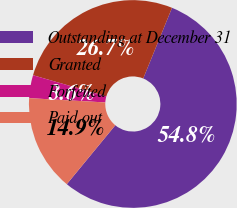Convert chart. <chart><loc_0><loc_0><loc_500><loc_500><pie_chart><fcel>Outstanding at December 31<fcel>Granted<fcel>Forfeited<fcel>Paid out<nl><fcel>54.8%<fcel>26.69%<fcel>3.57%<fcel>14.93%<nl></chart> 